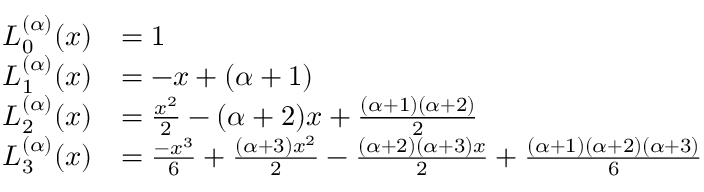Convert formula to latex. <formula><loc_0><loc_0><loc_500><loc_500>{ \begin{array} { r l } { L _ { 0 } ^ { ( \alpha ) } ( x ) } & { = 1 } \\ { L _ { 1 } ^ { ( \alpha ) } ( x ) } & { = - x + ( \alpha + 1 ) } \\ { L _ { 2 } ^ { ( \alpha ) } ( x ) } & { = { \frac { x ^ { 2 } } { 2 } } - ( \alpha + 2 ) x + { \frac { ( \alpha + 1 ) ( \alpha + 2 ) } { 2 } } } \\ { L _ { 3 } ^ { ( \alpha ) } ( x ) } & { = { \frac { - x ^ { 3 } } { 6 } } + { \frac { ( \alpha + 3 ) x ^ { 2 } } { 2 } } - { \frac { ( \alpha + 2 ) ( \alpha + 3 ) x } { 2 } } + { \frac { ( \alpha + 1 ) ( \alpha + 2 ) ( \alpha + 3 ) } { 6 } } } \end{array} }</formula> 